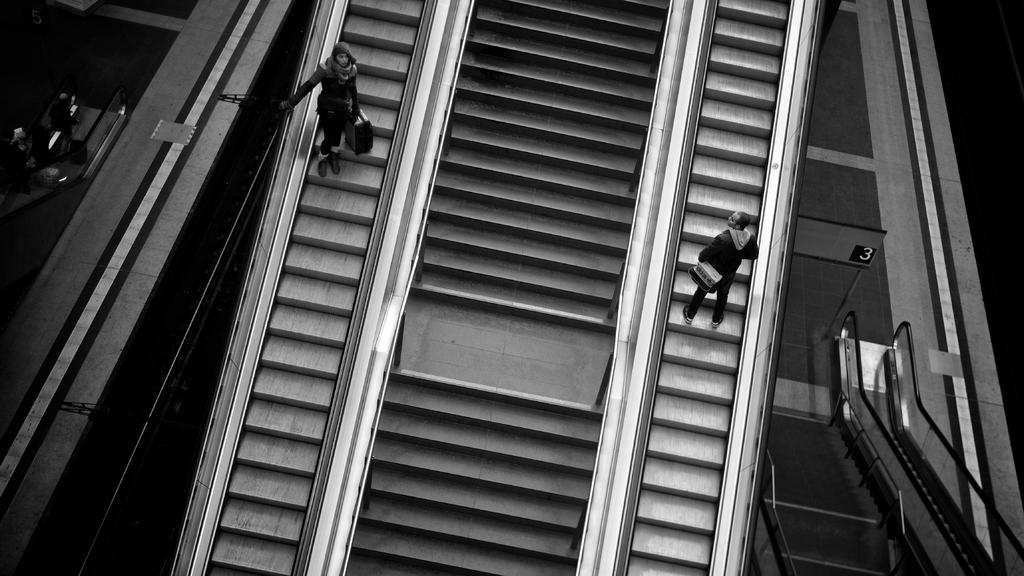What type of structure is present in the image that allows for vertical movement? There is a staircase in the image that allows for vertical movement. What are the two persons in the image doing? The two persons are standing on an escalator. Where is the escalator located in relation to the staircase? The escalator is on either side of the staircase. What type of smell can be detected coming from the staircase in the image? There is no information about smells in the image, so it cannot be determined. 